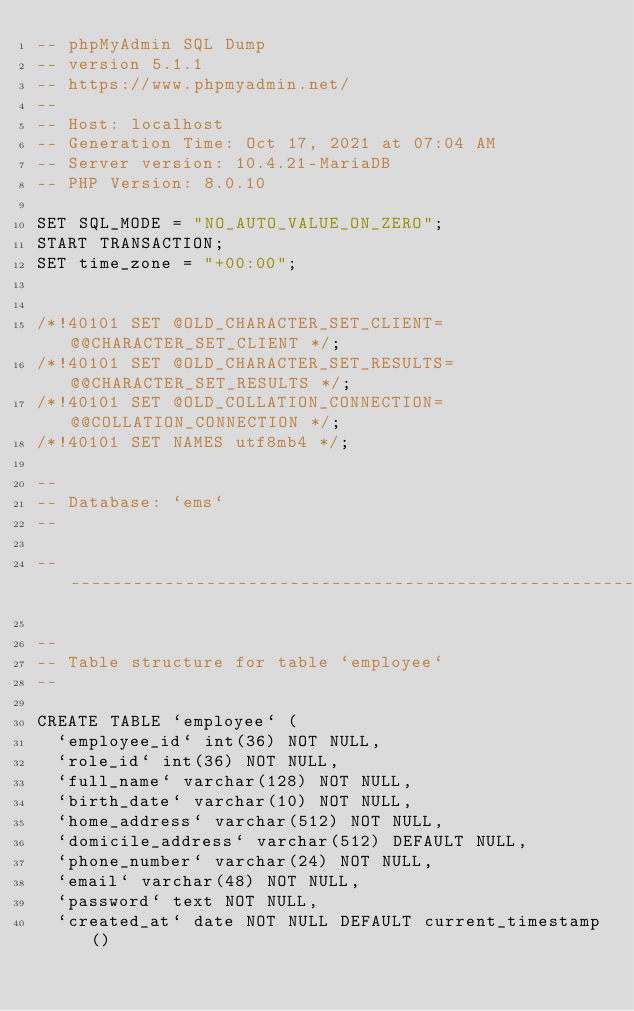Convert code to text. <code><loc_0><loc_0><loc_500><loc_500><_SQL_>-- phpMyAdmin SQL Dump
-- version 5.1.1
-- https://www.phpmyadmin.net/
--
-- Host: localhost
-- Generation Time: Oct 17, 2021 at 07:04 AM
-- Server version: 10.4.21-MariaDB
-- PHP Version: 8.0.10

SET SQL_MODE = "NO_AUTO_VALUE_ON_ZERO";
START TRANSACTION;
SET time_zone = "+00:00";


/*!40101 SET @OLD_CHARACTER_SET_CLIENT=@@CHARACTER_SET_CLIENT */;
/*!40101 SET @OLD_CHARACTER_SET_RESULTS=@@CHARACTER_SET_RESULTS */;
/*!40101 SET @OLD_COLLATION_CONNECTION=@@COLLATION_CONNECTION */;
/*!40101 SET NAMES utf8mb4 */;

--
-- Database: `ems`
--

-- --------------------------------------------------------

--
-- Table structure for table `employee`
--

CREATE TABLE `employee` (
  `employee_id` int(36) NOT NULL,
  `role_id` int(36) NOT NULL,
  `full_name` varchar(128) NOT NULL,
  `birth_date` varchar(10) NOT NULL,
  `home_address` varchar(512) NOT NULL,
  `domicile_address` varchar(512) DEFAULT NULL,
  `phone_number` varchar(24) NOT NULL,
  `email` varchar(48) NOT NULL,
  `password` text NOT NULL,
  `created_at` date NOT NULL DEFAULT current_timestamp()</code> 